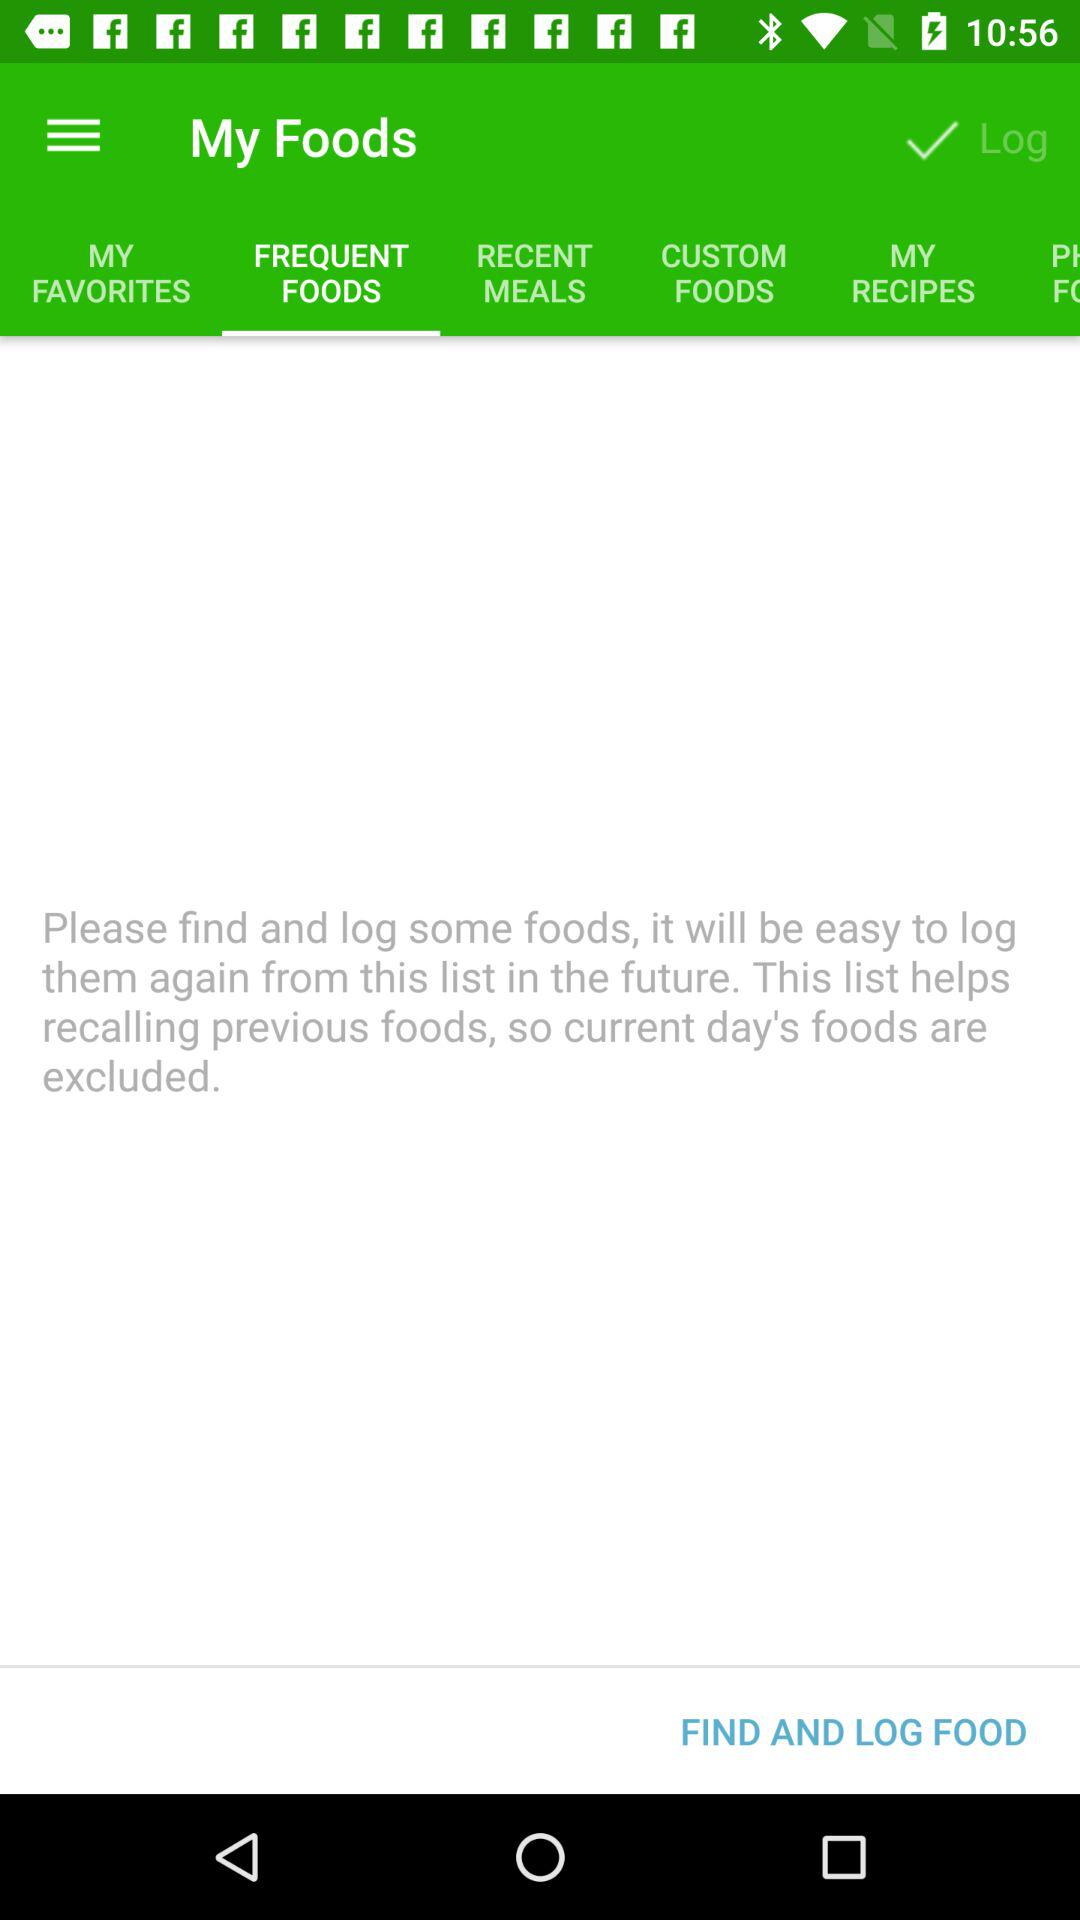How many food types are there to choose from?
Answer the question using a single word or phrase. 5 